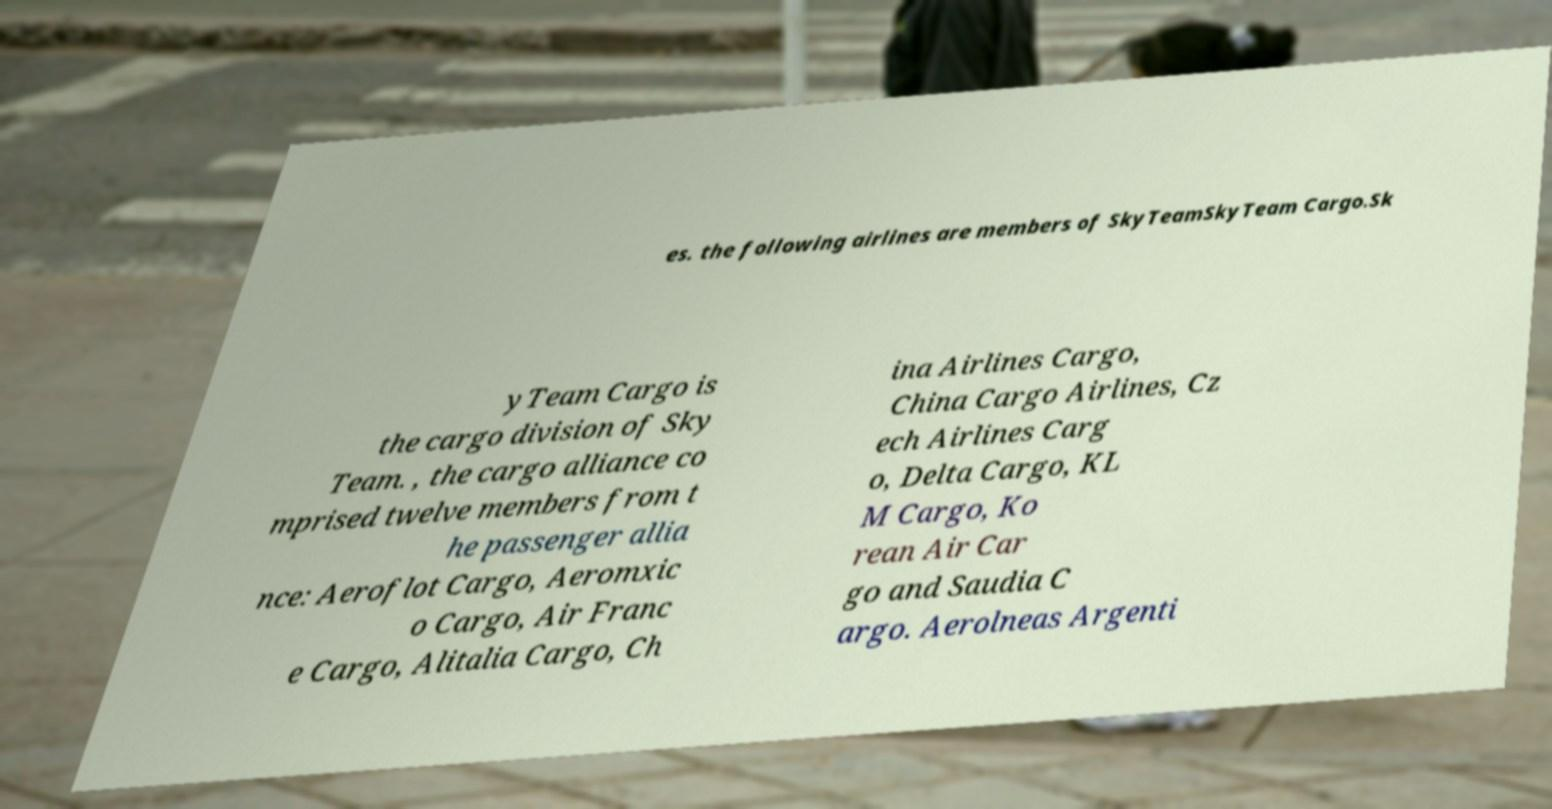Could you assist in decoding the text presented in this image and type it out clearly? es. the following airlines are members of SkyTeamSkyTeam Cargo.Sk yTeam Cargo is the cargo division of Sky Team. , the cargo alliance co mprised twelve members from t he passenger allia nce: Aeroflot Cargo, Aeromxic o Cargo, Air Franc e Cargo, Alitalia Cargo, Ch ina Airlines Cargo, China Cargo Airlines, Cz ech Airlines Carg o, Delta Cargo, KL M Cargo, Ko rean Air Car go and Saudia C argo. Aerolneas Argenti 